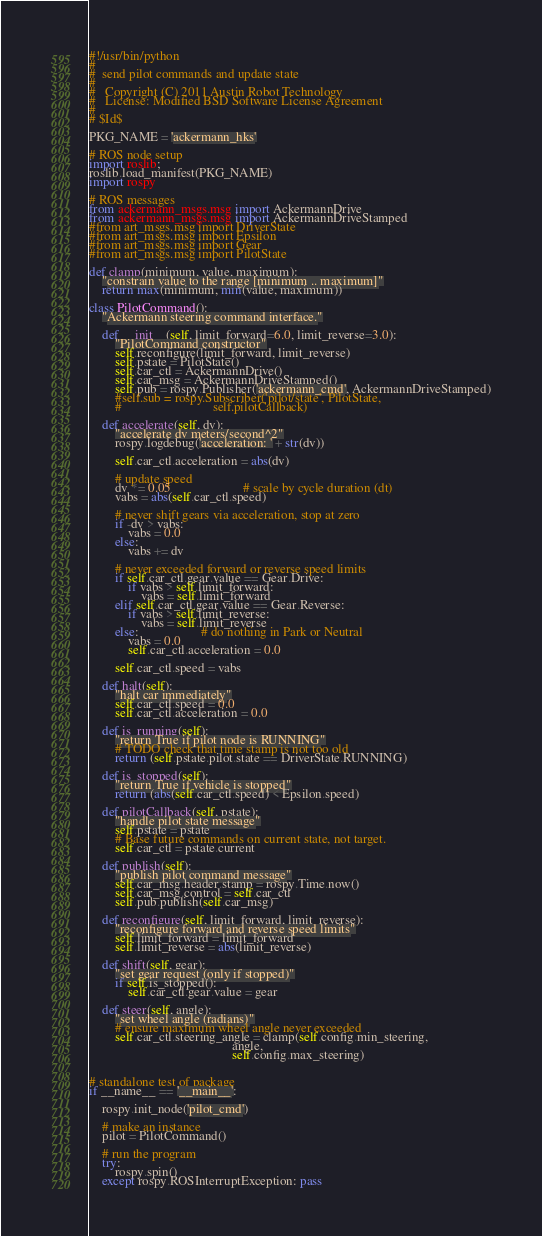<code> <loc_0><loc_0><loc_500><loc_500><_Python_>#!/usr/bin/python
#
#  send pilot commands and update state
#
#   Copyright (C) 2011 Austin Robot Technology
#   License: Modified BSD Software License Agreement
#
# $Id$

PKG_NAME = 'ackermann_hks'

# ROS node setup
import roslib;
roslib.load_manifest(PKG_NAME)
import rospy

# ROS messages
from ackermann_msgs.msg import AckermannDrive
from ackermann_msgs.msg import AckermannDriveStamped
#from art_msgs.msg import DriverState
#from art_msgs.msg import Epsilon
#from art_msgs.msg import Gear
#from art_msgs.msg import PilotState

def clamp(minimum, value, maximum):
    "constrain value to the range [minimum .. maximum]"
    return max(minimum, min(value, maximum))

class PilotCommand():
    "Ackermann steering command interface."

    def __init__(self, limit_forward=6.0, limit_reverse=3.0):
        "PilotCommand constructor"
        self.reconfigure(limit_forward, limit_reverse)
        self.pstate = PilotState()
        self.car_ctl = AckermannDrive()
        self.car_msg = AckermannDriveStamped()
        self.pub = rospy.Publisher('ackermann_cmd', AckermannDriveStamped)
        #self.sub = rospy.Subscriber('pilot/state', PilotState,
        #                            self.pilotCallback)

    def accelerate(self, dv):
        "accelerate dv meters/second^2"
        rospy.logdebug('acceleration: ' + str(dv))

        self.car_ctl.acceleration = abs(dv)

        # update speed
        dv *= 0.05                      # scale by cycle duration (dt)
        vabs = abs(self.car_ctl.speed)

        # never shift gears via acceleration, stop at zero
        if -dv > vabs:
            vabs = 0.0
        else:
            vabs += dv

        # never exceeded forward or reverse speed limits
        if self.car_ctl.gear.value == Gear.Drive:
            if vabs > self.limit_forward:
                vabs = self.limit_forward
        elif self.car_ctl.gear.value == Gear.Reverse:
            if vabs > self.limit_reverse:
                vabs = self.limit_reverse
        else:                   # do nothing in Park or Neutral
            vabs = 0.0
            self.car_ctl.acceleration = 0.0

        self.car_ctl.speed = vabs

    def halt(self):
        "halt car immediately"
        self.car_ctl.speed = 0.0
        self.car_ctl.acceleration = 0.0

    def is_running(self):
        "return True if pilot node is RUNNING"
        # TODO check that time stamp is not too old
        return (self.pstate.pilot.state == DriverState.RUNNING)

    def is_stopped(self):
        "return True if vehicle is stopped"
        return (abs(self.car_ctl.speed) < Epsilon.speed)

    def pilotCallback(self, pstate):
        "handle pilot state message"
        self.pstate = pstate
        # Base future commands on current state, not target.
        self.car_ctl = pstate.current

    def publish(self):
        "publish pilot command message"
        self.car_msg.header.stamp = rospy.Time.now()
        self.car_msg.control = self.car_ctl
        self.pub.publish(self.car_msg)

    def reconfigure(self, limit_forward, limit_reverse):
        "reconfigure forward and reverse speed limits"
        self.limit_forward = limit_forward
        self.limit_reverse = abs(limit_reverse)

    def shift(self, gear):
        "set gear request (only if stopped)"
        if self.is_stopped():
            self.car_ctl.gear.value = gear

    def steer(self, angle):
        "set wheel angle (radians)"
        # ensure maximum wheel angle never exceeded
        self.car_ctl.steering_angle = clamp(self.config.min_steering,
                                            angle,
                                            self.config.max_steering)


# standalone test of package
if __name__ == '__main__':

    rospy.init_node('pilot_cmd')

    # make an instance
    pilot = PilotCommand()

    # run the program
    try:
        rospy.spin()
    except rospy.ROSInterruptException: pass
</code> 